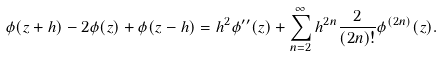<formula> <loc_0><loc_0><loc_500><loc_500>\phi ( z + h ) - 2 \phi ( z ) + \phi ( z - h ) = h ^ { 2 } \phi ^ { \prime \prime } ( z ) + \sum _ { n = 2 } ^ { \infty } h ^ { 2 n } \frac { 2 } { ( 2 n ) ! } \phi ^ { ( 2 n ) } ( z ) .</formula> 